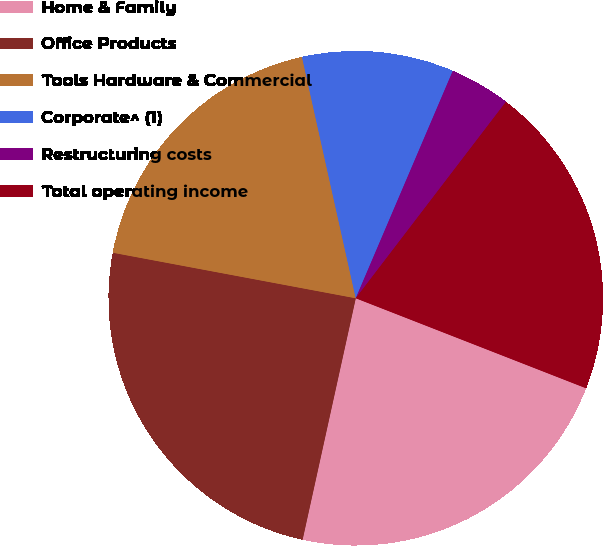Convert chart to OTSL. <chart><loc_0><loc_0><loc_500><loc_500><pie_chart><fcel>Home & Family<fcel>Office Products<fcel>Tools Hardware & Commercial<fcel>Corporate^ (1)<fcel>Restructuring costs<fcel>Total operating income<nl><fcel>22.52%<fcel>24.5%<fcel>18.56%<fcel>9.91%<fcel>3.97%<fcel>20.54%<nl></chart> 